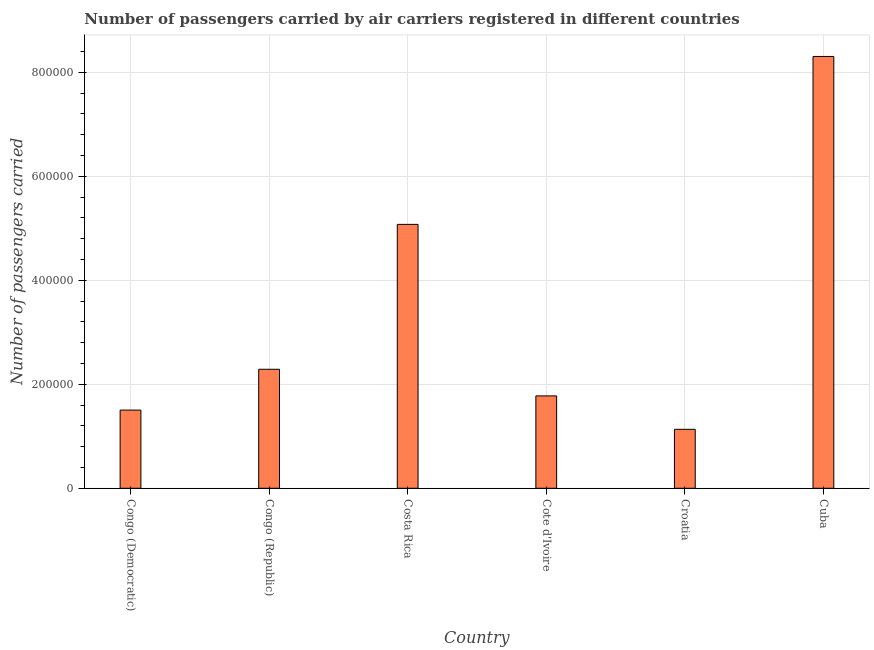Does the graph contain grids?
Your answer should be compact. Yes. What is the title of the graph?
Ensure brevity in your answer.  Number of passengers carried by air carriers registered in different countries. What is the label or title of the X-axis?
Keep it short and to the point. Country. What is the label or title of the Y-axis?
Your answer should be very brief. Number of passengers carried. What is the number of passengers carried in Croatia?
Make the answer very short. 1.13e+05. Across all countries, what is the maximum number of passengers carried?
Your response must be concise. 8.31e+05. Across all countries, what is the minimum number of passengers carried?
Ensure brevity in your answer.  1.13e+05. In which country was the number of passengers carried maximum?
Make the answer very short. Cuba. In which country was the number of passengers carried minimum?
Give a very brief answer. Croatia. What is the sum of the number of passengers carried?
Make the answer very short. 2.01e+06. What is the difference between the number of passengers carried in Congo (Democratic) and Costa Rica?
Your response must be concise. -3.57e+05. What is the average number of passengers carried per country?
Your response must be concise. 3.35e+05. What is the median number of passengers carried?
Provide a succinct answer. 2.03e+05. In how many countries, is the number of passengers carried greater than 120000 ?
Give a very brief answer. 5. What is the ratio of the number of passengers carried in Congo (Republic) to that in Cote d'Ivoire?
Provide a succinct answer. 1.29. Is the difference between the number of passengers carried in Congo (Republic) and Costa Rica greater than the difference between any two countries?
Offer a very short reply. No. What is the difference between the highest and the second highest number of passengers carried?
Provide a short and direct response. 3.23e+05. Is the sum of the number of passengers carried in Congo (Democratic) and Costa Rica greater than the maximum number of passengers carried across all countries?
Provide a succinct answer. No. What is the difference between the highest and the lowest number of passengers carried?
Your answer should be very brief. 7.17e+05. In how many countries, is the number of passengers carried greater than the average number of passengers carried taken over all countries?
Ensure brevity in your answer.  2. How many bars are there?
Keep it short and to the point. 6. How many countries are there in the graph?
Offer a very short reply. 6. What is the difference between two consecutive major ticks on the Y-axis?
Your answer should be compact. 2.00e+05. What is the Number of passengers carried of Congo (Democratic)?
Your answer should be very brief. 1.50e+05. What is the Number of passengers carried of Congo (Republic)?
Offer a terse response. 2.29e+05. What is the Number of passengers carried of Costa Rica?
Your answer should be very brief. 5.08e+05. What is the Number of passengers carried in Cote d'Ivoire?
Your answer should be very brief. 1.78e+05. What is the Number of passengers carried of Croatia?
Offer a very short reply. 1.13e+05. What is the Number of passengers carried in Cuba?
Your answer should be compact. 8.31e+05. What is the difference between the Number of passengers carried in Congo (Democratic) and Congo (Republic)?
Make the answer very short. -7.85e+04. What is the difference between the Number of passengers carried in Congo (Democratic) and Costa Rica?
Ensure brevity in your answer.  -3.57e+05. What is the difference between the Number of passengers carried in Congo (Democratic) and Cote d'Ivoire?
Offer a terse response. -2.73e+04. What is the difference between the Number of passengers carried in Congo (Democratic) and Croatia?
Make the answer very short. 3.70e+04. What is the difference between the Number of passengers carried in Congo (Democratic) and Cuba?
Your answer should be very brief. -6.80e+05. What is the difference between the Number of passengers carried in Congo (Republic) and Costa Rica?
Offer a terse response. -2.79e+05. What is the difference between the Number of passengers carried in Congo (Republic) and Cote d'Ivoire?
Your answer should be very brief. 5.12e+04. What is the difference between the Number of passengers carried in Congo (Republic) and Croatia?
Your answer should be very brief. 1.16e+05. What is the difference between the Number of passengers carried in Congo (Republic) and Cuba?
Ensure brevity in your answer.  -6.02e+05. What is the difference between the Number of passengers carried in Costa Rica and Cote d'Ivoire?
Your answer should be very brief. 3.30e+05. What is the difference between the Number of passengers carried in Costa Rica and Croatia?
Give a very brief answer. 3.94e+05. What is the difference between the Number of passengers carried in Costa Rica and Cuba?
Offer a terse response. -3.23e+05. What is the difference between the Number of passengers carried in Cote d'Ivoire and Croatia?
Keep it short and to the point. 6.43e+04. What is the difference between the Number of passengers carried in Cote d'Ivoire and Cuba?
Offer a very short reply. -6.53e+05. What is the difference between the Number of passengers carried in Croatia and Cuba?
Offer a terse response. -7.17e+05. What is the ratio of the Number of passengers carried in Congo (Democratic) to that in Congo (Republic)?
Make the answer very short. 0.66. What is the ratio of the Number of passengers carried in Congo (Democratic) to that in Costa Rica?
Offer a very short reply. 0.3. What is the ratio of the Number of passengers carried in Congo (Democratic) to that in Cote d'Ivoire?
Your answer should be compact. 0.85. What is the ratio of the Number of passengers carried in Congo (Democratic) to that in Croatia?
Your answer should be compact. 1.33. What is the ratio of the Number of passengers carried in Congo (Democratic) to that in Cuba?
Your response must be concise. 0.18. What is the ratio of the Number of passengers carried in Congo (Republic) to that in Costa Rica?
Provide a succinct answer. 0.45. What is the ratio of the Number of passengers carried in Congo (Republic) to that in Cote d'Ivoire?
Provide a succinct answer. 1.29. What is the ratio of the Number of passengers carried in Congo (Republic) to that in Croatia?
Provide a succinct answer. 2.02. What is the ratio of the Number of passengers carried in Congo (Republic) to that in Cuba?
Keep it short and to the point. 0.28. What is the ratio of the Number of passengers carried in Costa Rica to that in Cote d'Ivoire?
Offer a terse response. 2.86. What is the ratio of the Number of passengers carried in Costa Rica to that in Croatia?
Offer a very short reply. 4.48. What is the ratio of the Number of passengers carried in Costa Rica to that in Cuba?
Your answer should be very brief. 0.61. What is the ratio of the Number of passengers carried in Cote d'Ivoire to that in Croatia?
Offer a terse response. 1.57. What is the ratio of the Number of passengers carried in Cote d'Ivoire to that in Cuba?
Offer a very short reply. 0.21. What is the ratio of the Number of passengers carried in Croatia to that in Cuba?
Provide a short and direct response. 0.14. 